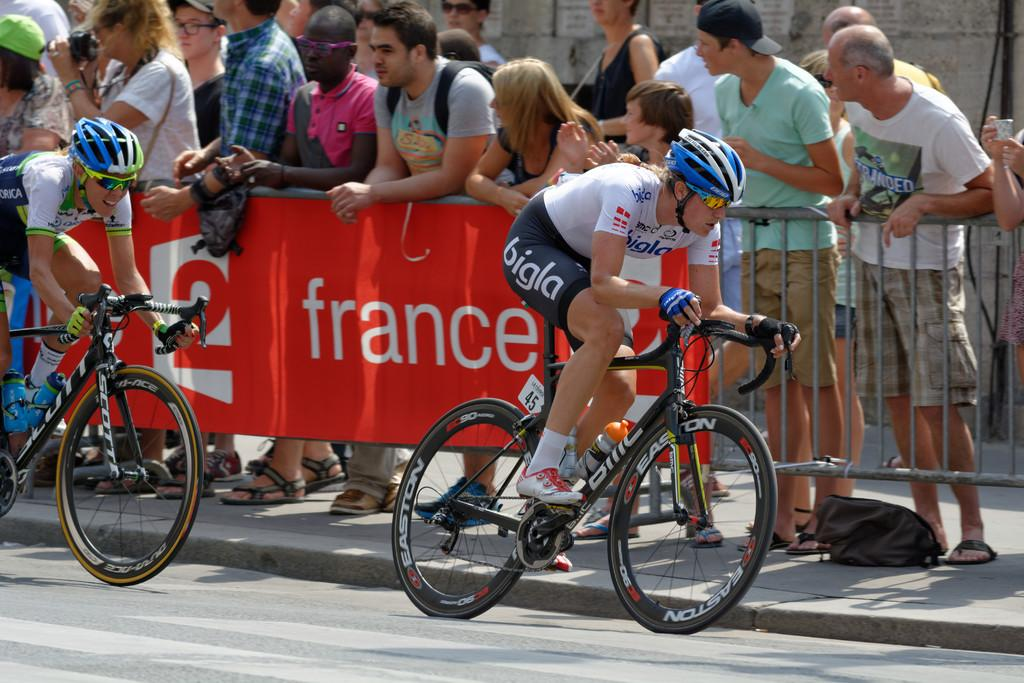How many people are in the image? There are two persons in the image. What protective gear are the persons wearing? Both persons are wearing helmets and goggles. What activity are the persons engaged in? They are riding bicycles. Where are the bicycles located? The bicycles are on a road. What can be seen in the background of the image? There is a group of people in the background, and they are looking at the two persons. What is the purpose of the fence in the background? The fence is present in the background, but its purpose is not specified in the facts. What is written on the banner with the fence? The facts do not mention the content of the banner. What type of chicken is being used for pleasure in the image? There is no chicken present in the image, and the concept of using a chicken for pleasure is not relevant to the image. 